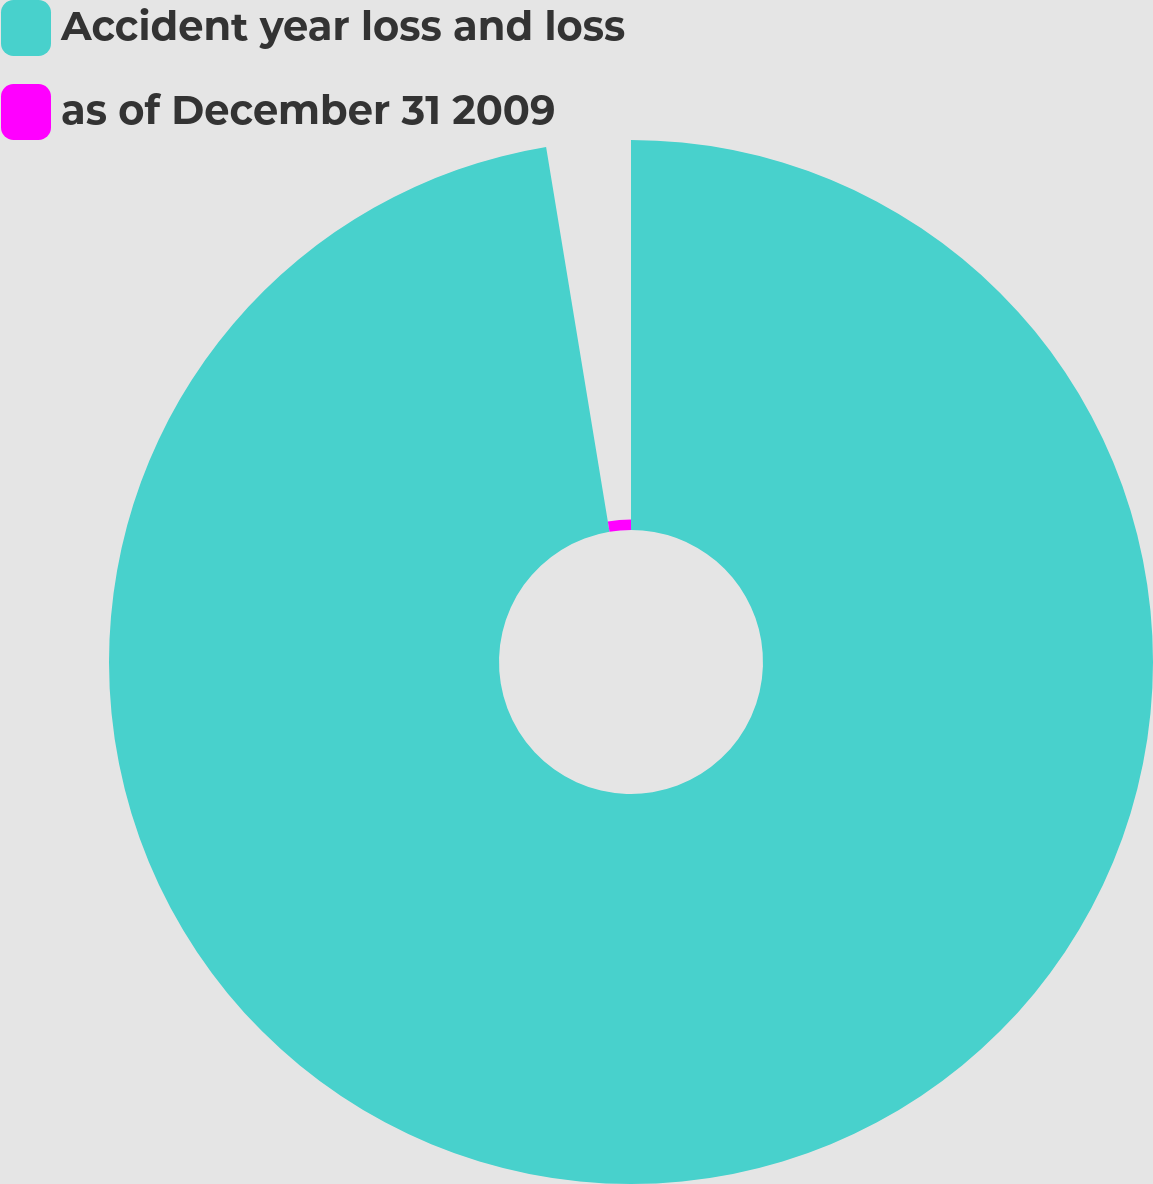Convert chart. <chart><loc_0><loc_0><loc_500><loc_500><pie_chart><fcel>Accident year loss and loss<fcel>as of December 31 2009<nl><fcel>97.4%<fcel>2.6%<nl></chart> 